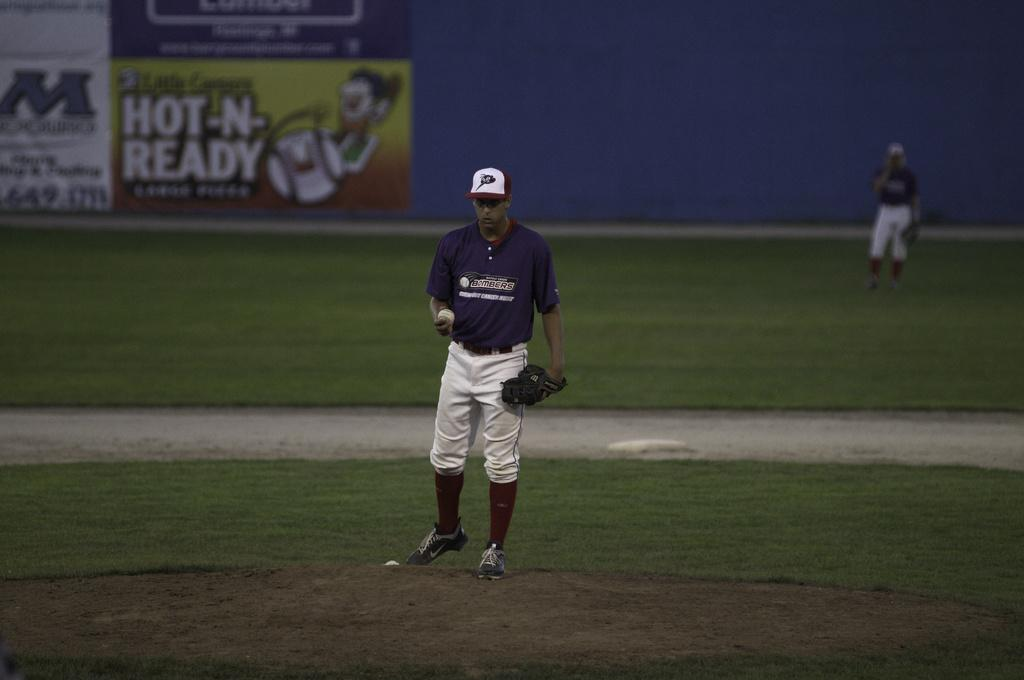<image>
Offer a succinct explanation of the picture presented. In the the background a banner is advertising HOT-N-READY. 